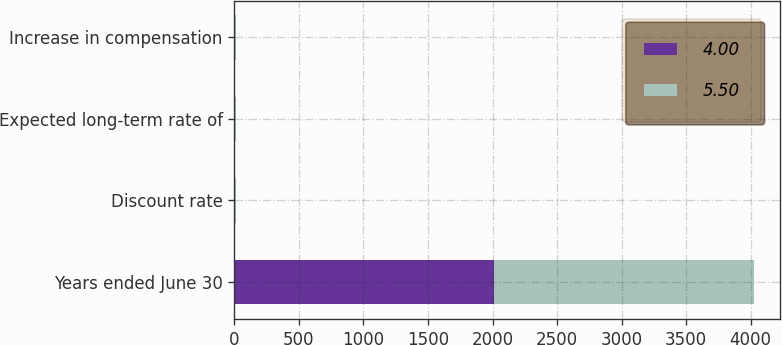<chart> <loc_0><loc_0><loc_500><loc_500><stacked_bar_chart><ecel><fcel>Years ended June 30<fcel>Discount rate<fcel>Expected long-term rate of<fcel>Increase in compensation<nl><fcel>4<fcel>2012<fcel>5.4<fcel>7.25<fcel>4<nl><fcel>5.5<fcel>2011<fcel>5.25<fcel>7.25<fcel>5.5<nl></chart> 